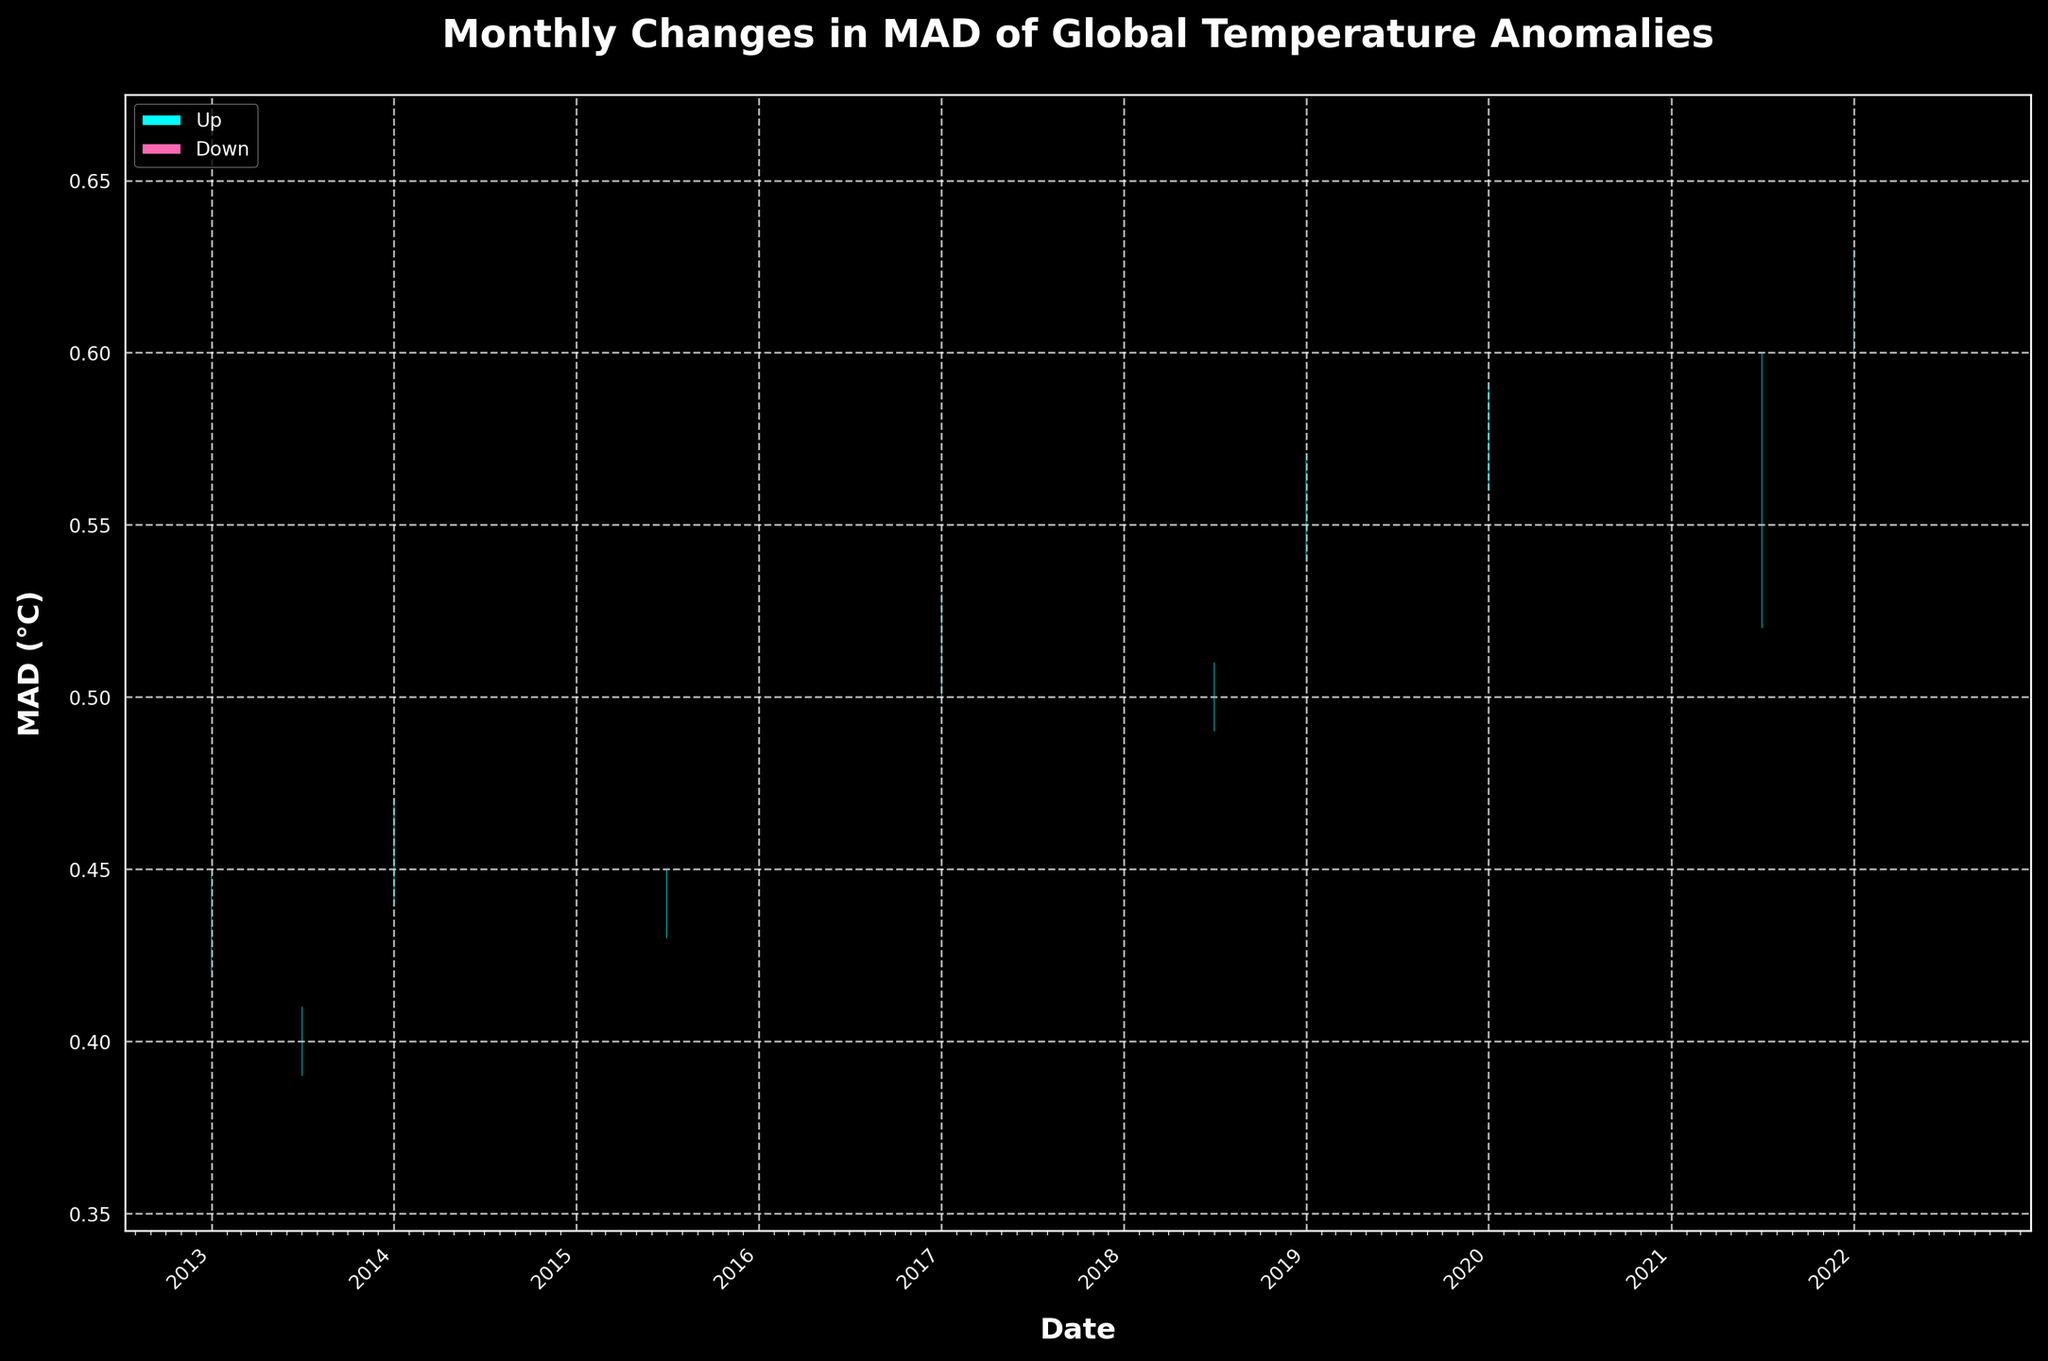What is the title of the chart? The title of the chart is displayed prominently at the top of the figure. It reads "Monthly Changes in MAD of Global Temperature Anomalies".
Answer: Monthly Changes in MAD of Global Temperature Anomalies How many data points are plotted on the chart? Each data point corresponds to a distinct month across the past decade. By counting the number of individual candlesticks, we can determine the number of data points plotted.
Answer: 20 What does a candlestick colored in cyan represent? In the chart's legend, cyan indicates 'Up'. This means that the close value for that month was higher than the open value.
Answer: An 'Up' month where the Close value is higher than the Open value Which month had the highest MAD value? The highest MAD value can be identified by finding the month with the highest top end of the high value in the candlestick. January 2022 has the highest high value at 0.66.
Answer: January 2022 What was the MAD value at the close of January 2020? To find this, look for the candlestick representing January 2020 and determine the position at its close value, which is 0.59.
Answer: 0.59 Which month experienced the largest range between the high and the low values? To determine this, calculate the range (high - low) for each month and identify the largest difference. January 2021 had a high of 0.64 and a low of 0.55, so the range is 0.64 - 0.55 = 0.09.
Answer: January 2021 What general trend can be observed in the MAD values over the decade? By observing the overall pattern of the candlesticks from left to right on the X-axis, a general upward trend is noticeable, indicating that MAD values have increased over the decade.
Answer: An upward trend in MAD values In which year did the MAD close value exceed 0.6 for the first time? By scanning the chart, identify the first instance where the close value of a cyan or pink candlestick exceeds 0.6. This occurs in January 2020.
Answer: 2020 How do the "Up" and "Down" months alternate from 2013 to 2022? Identify patterns between cyan (up) and pink (down) candlesticks over the chart. For example, each January and July often shows a pattern. One possible approach is to list the observed months: 2013 down, 2014 up, 2015 down, 2016 up, and so on with some exceptions.
Answer: They mostly alternate each year, with some exceptions Which month had the smallest change between its opening and closing MAD values? This involves comparing the difference (absolute value) between open and close values for each month; the smallest value is the one with minimal change. July 2013 has the smallest change from Open 0.39 to Close 0.41 giving an absolute difference of 0.02.
Answer: July 2013 